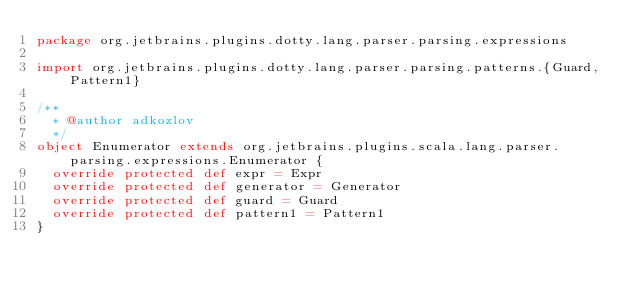<code> <loc_0><loc_0><loc_500><loc_500><_Scala_>package org.jetbrains.plugins.dotty.lang.parser.parsing.expressions

import org.jetbrains.plugins.dotty.lang.parser.parsing.patterns.{Guard, Pattern1}

/**
  * @author adkozlov
  */
object Enumerator extends org.jetbrains.plugins.scala.lang.parser.parsing.expressions.Enumerator {
  override protected def expr = Expr
  override protected def generator = Generator
  override protected def guard = Guard
  override protected def pattern1 = Pattern1
}
</code> 